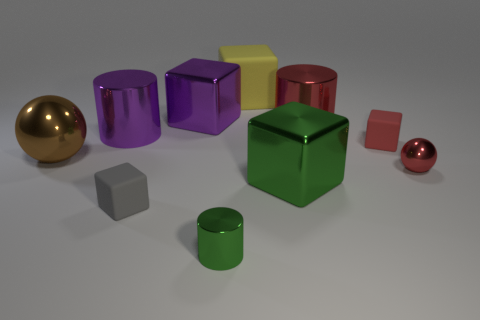Does the red metal thing in front of the brown thing have the same size as the brown shiny thing?
Provide a short and direct response. No. What number of other objects are there of the same size as the red matte cube?
Keep it short and to the point. 3. What is the color of the tiny cylinder?
Keep it short and to the point. Green. There is a small cube that is in front of the small red block; what is its material?
Offer a very short reply. Rubber. Is the number of large things in front of the gray matte cube the same as the number of tiny purple matte blocks?
Your response must be concise. Yes. Do the big rubber thing and the large red metallic object have the same shape?
Your answer should be very brief. No. Are there any other things that are the same color as the tiny ball?
Make the answer very short. Yes. There is a large thing that is both left of the big yellow matte block and right of the big purple metallic cylinder; what shape is it?
Provide a short and direct response. Cube. Are there the same number of shiny blocks behind the purple cube and small matte things on the left side of the small red matte cube?
Your answer should be compact. No. How many balls are big purple shiny objects or gray things?
Make the answer very short. 0. 